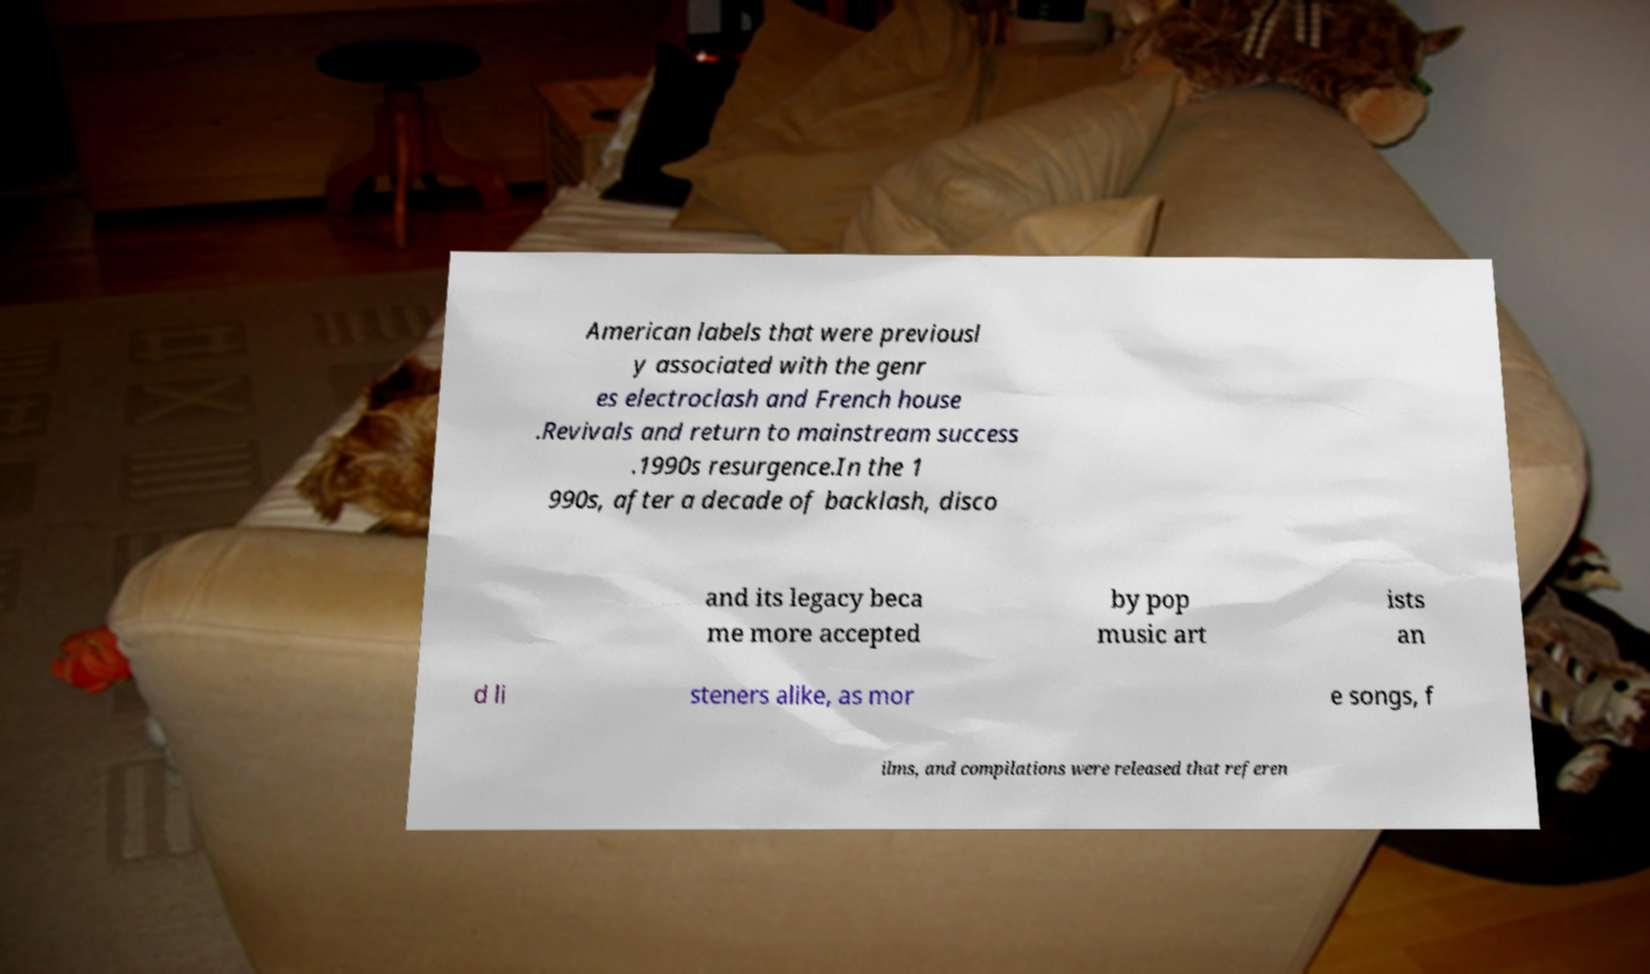For documentation purposes, I need the text within this image transcribed. Could you provide that? American labels that were previousl y associated with the genr es electroclash and French house .Revivals and return to mainstream success .1990s resurgence.In the 1 990s, after a decade of backlash, disco and its legacy beca me more accepted by pop music art ists an d li steners alike, as mor e songs, f ilms, and compilations were released that referen 